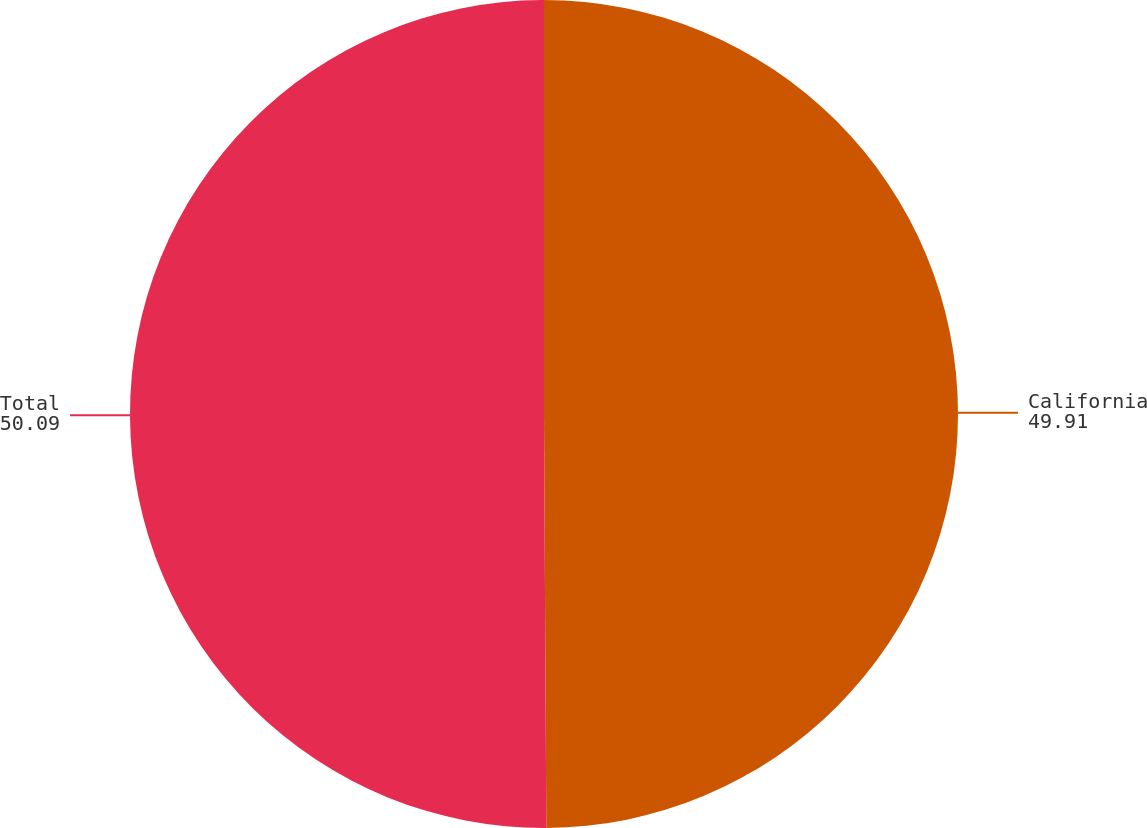Convert chart to OTSL. <chart><loc_0><loc_0><loc_500><loc_500><pie_chart><fcel>California<fcel>Total<nl><fcel>49.91%<fcel>50.09%<nl></chart> 